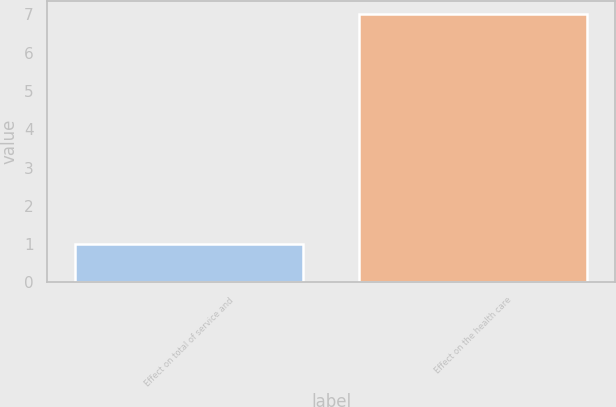Convert chart to OTSL. <chart><loc_0><loc_0><loc_500><loc_500><bar_chart><fcel>Effect on total of service and<fcel>Effect on the health care<nl><fcel>1<fcel>7<nl></chart> 